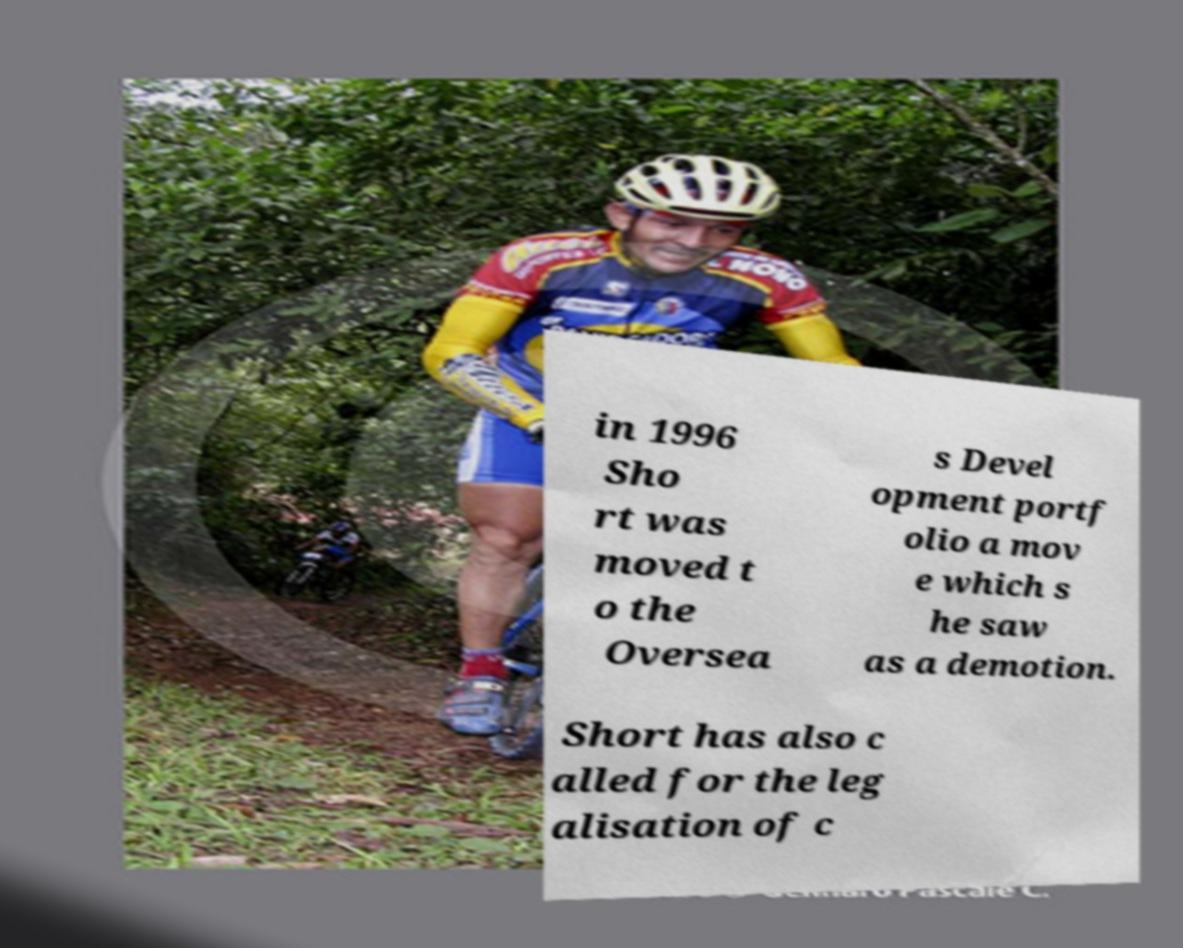Please identify and transcribe the text found in this image. in 1996 Sho rt was moved t o the Oversea s Devel opment portf olio a mov e which s he saw as a demotion. Short has also c alled for the leg alisation of c 